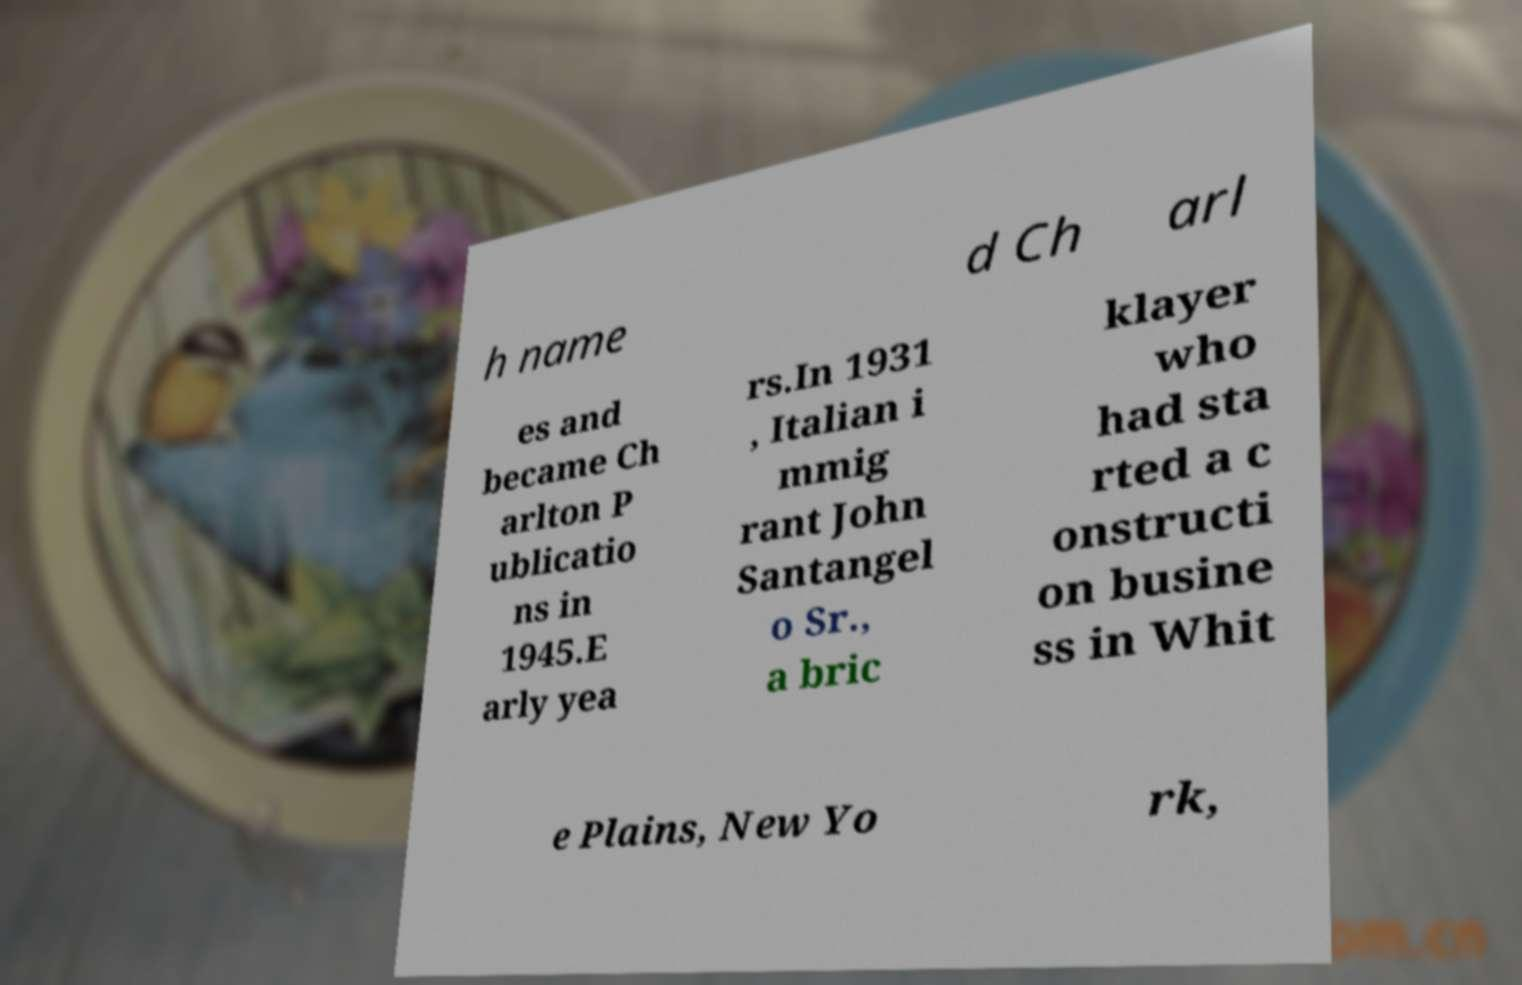Please read and relay the text visible in this image. What does it say? h name d Ch arl es and became Ch arlton P ublicatio ns in 1945.E arly yea rs.In 1931 , Italian i mmig rant John Santangel o Sr., a bric klayer who had sta rted a c onstructi on busine ss in Whit e Plains, New Yo rk, 